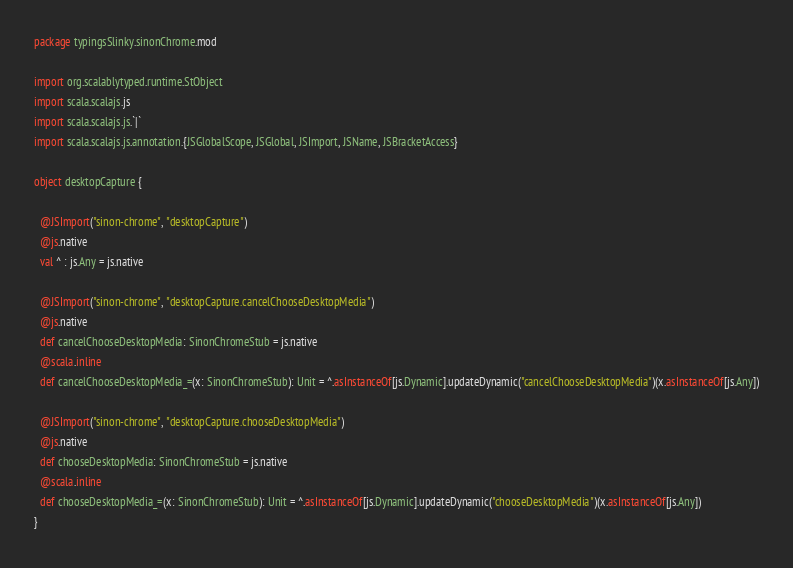Convert code to text. <code><loc_0><loc_0><loc_500><loc_500><_Scala_>package typingsSlinky.sinonChrome.mod

import org.scalablytyped.runtime.StObject
import scala.scalajs.js
import scala.scalajs.js.`|`
import scala.scalajs.js.annotation.{JSGlobalScope, JSGlobal, JSImport, JSName, JSBracketAccess}

object desktopCapture {
  
  @JSImport("sinon-chrome", "desktopCapture")
  @js.native
  val ^ : js.Any = js.native
  
  @JSImport("sinon-chrome", "desktopCapture.cancelChooseDesktopMedia")
  @js.native
  def cancelChooseDesktopMedia: SinonChromeStub = js.native
  @scala.inline
  def cancelChooseDesktopMedia_=(x: SinonChromeStub): Unit = ^.asInstanceOf[js.Dynamic].updateDynamic("cancelChooseDesktopMedia")(x.asInstanceOf[js.Any])
  
  @JSImport("sinon-chrome", "desktopCapture.chooseDesktopMedia")
  @js.native
  def chooseDesktopMedia: SinonChromeStub = js.native
  @scala.inline
  def chooseDesktopMedia_=(x: SinonChromeStub): Unit = ^.asInstanceOf[js.Dynamic].updateDynamic("chooseDesktopMedia")(x.asInstanceOf[js.Any])
}
</code> 